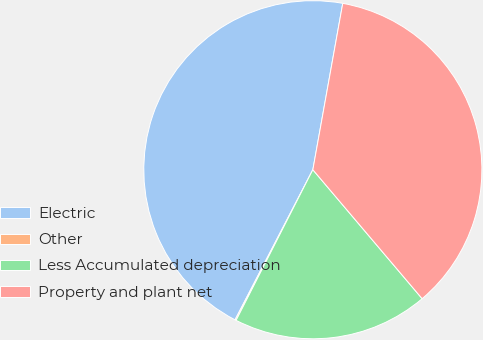<chart> <loc_0><loc_0><loc_500><loc_500><pie_chart><fcel>Electric<fcel>Other<fcel>Less Accumulated depreciation<fcel>Property and plant net<nl><fcel>45.22%<fcel>0.11%<fcel>18.69%<fcel>35.98%<nl></chart> 